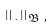Convert formula to latex. <formula><loc_0><loc_0><loc_500><loc_500>\left \| . \right \| _ { \mathfrak { B } } ,</formula> 